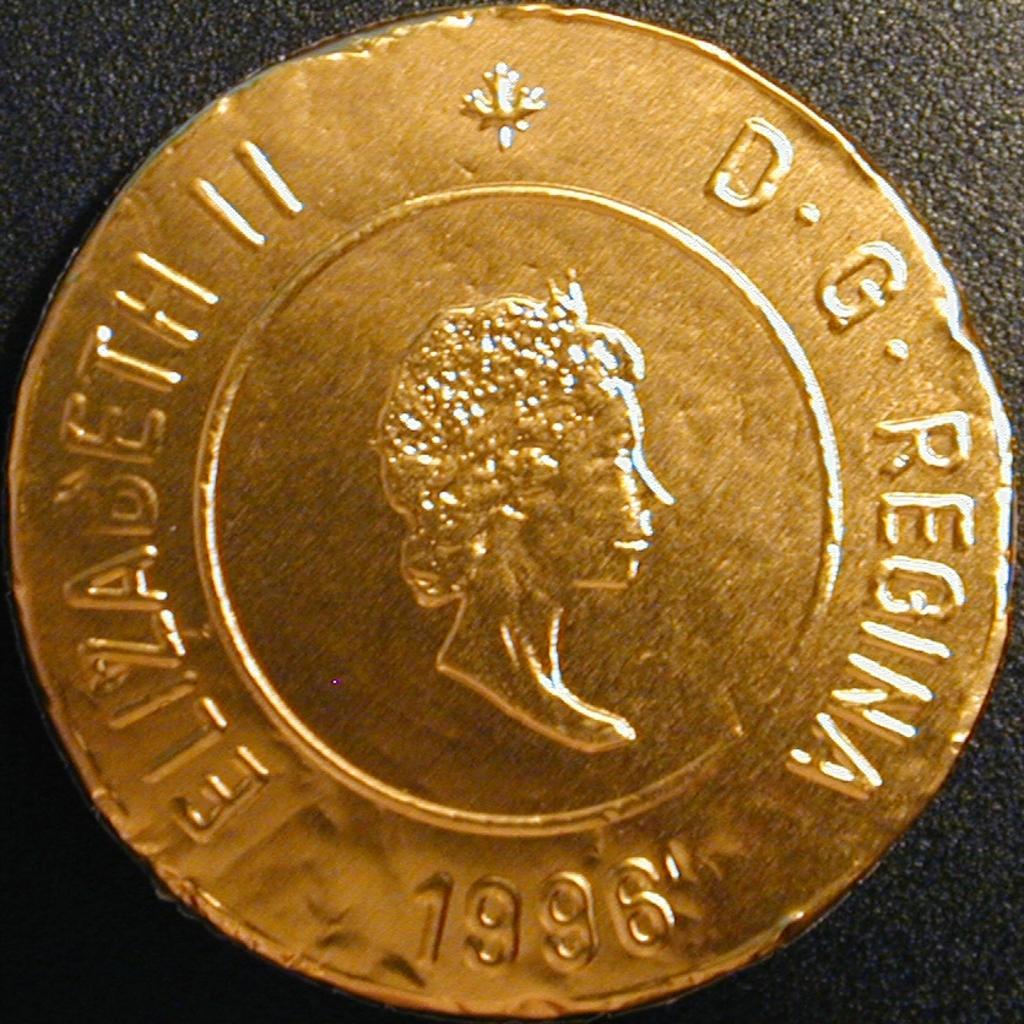Describe this image in one or two sentences. In this image we can see a coin placed on the surface. 